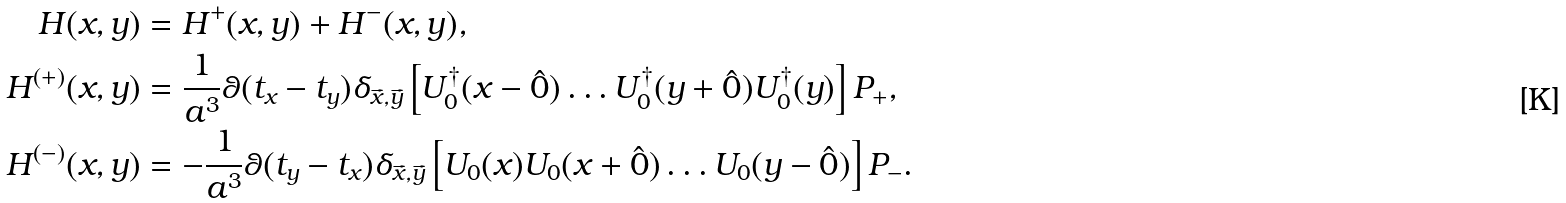<formula> <loc_0><loc_0><loc_500><loc_500>H ( x , y ) & = H ^ { + } ( x , y ) + H ^ { - } ( x , y ) , \\ H ^ { ( + ) } ( x , y ) & = \frac { 1 } { a ^ { 3 } } \theta ( t _ { x } - t _ { y } ) \delta _ { { \vec { x } } , { \vec { y } } } \left [ U ^ { \dagger } _ { 0 } ( x - \hat { 0 } ) \dots U ^ { \dagger } _ { 0 } ( y + \hat { 0 } ) U ^ { \dagger } _ { 0 } ( y ) \right ] P _ { + } , \\ H ^ { ( - ) } ( x , y ) & = - \frac { 1 } { a ^ { 3 } } \theta ( t _ { y } - t _ { x } ) \delta _ { { \vec { x } } , { \vec { y } } } \left [ U _ { 0 } ( x ) U _ { 0 } ( x + \hat { 0 } ) \dots U _ { 0 } ( y - \hat { 0 } ) \right ] P _ { - } .</formula> 